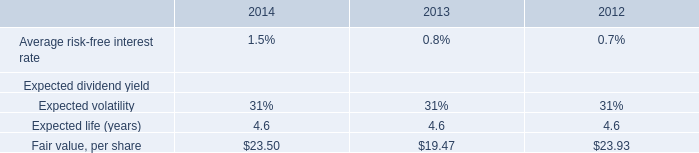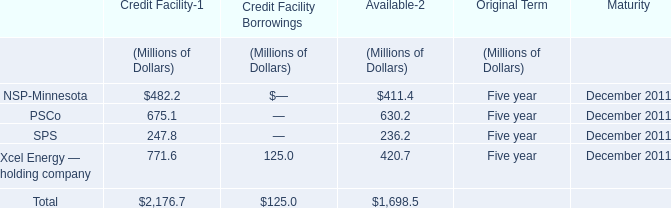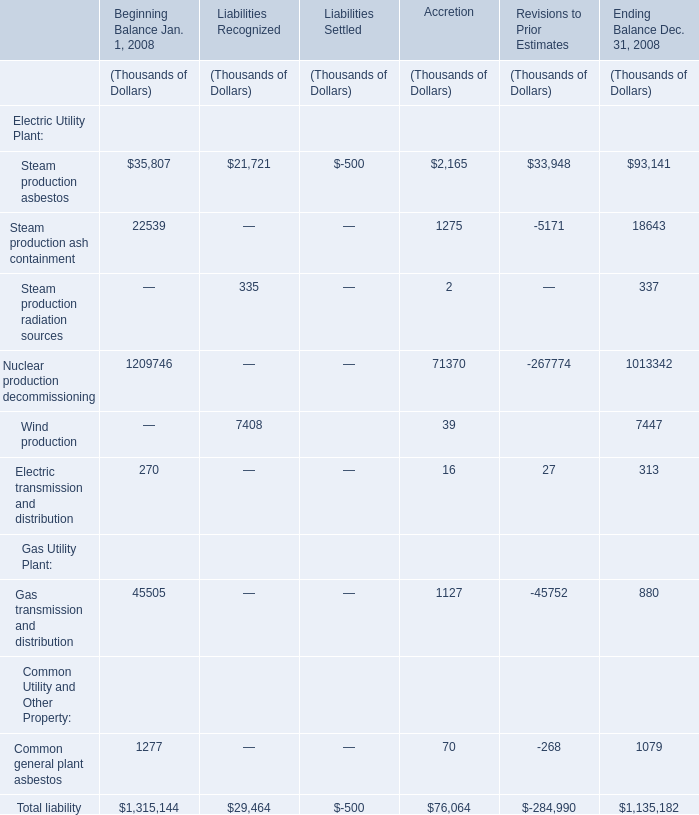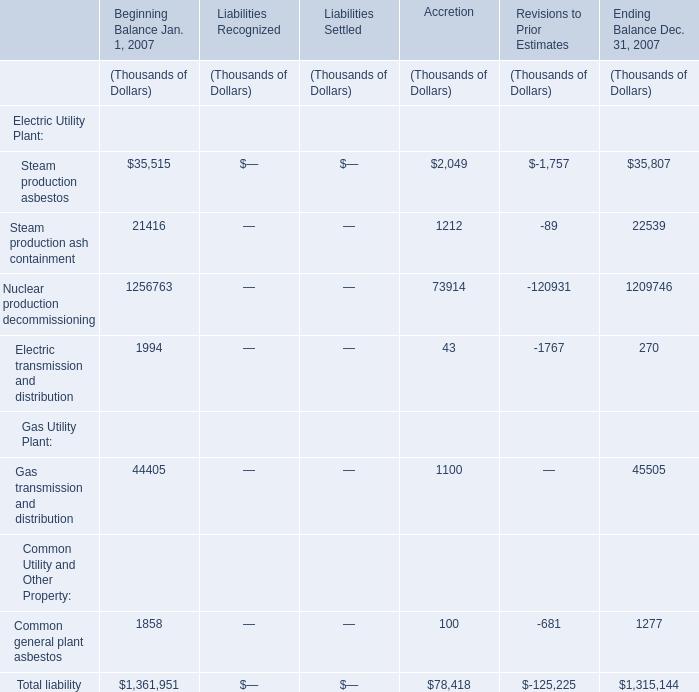What's the 30% of total liability in Ending Balance Dec. 31, 2007 ? 
Computations: (1315144 * 0.3)
Answer: 394543.2. 